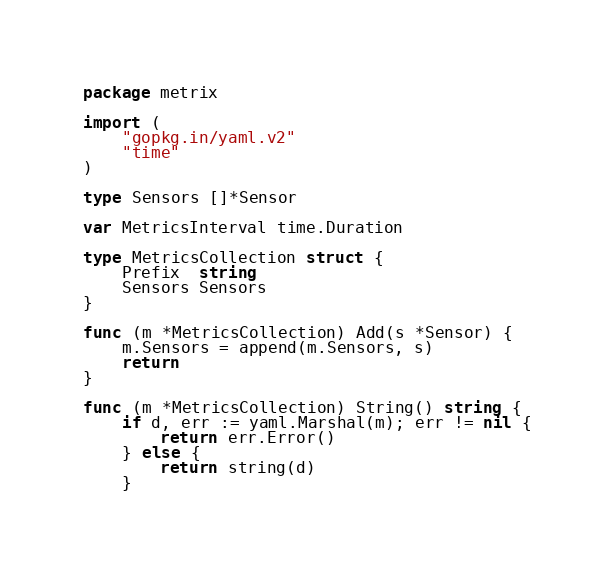<code> <loc_0><loc_0><loc_500><loc_500><_Go_>package metrix

import (
	"gopkg.in/yaml.v2"
	"time"
)

type Sensors []*Sensor

var MetricsInterval time.Duration

type MetricsCollection struct {
	Prefix  string
	Sensors Sensors
}

func (m *MetricsCollection) Add(s *Sensor) {
	m.Sensors = append(m.Sensors, s)
	return
}

func (m *MetricsCollection) String() string {
	if d, err := yaml.Marshal(m); err != nil {
		return err.Error()
	} else {
		return string(d)
	}</code> 